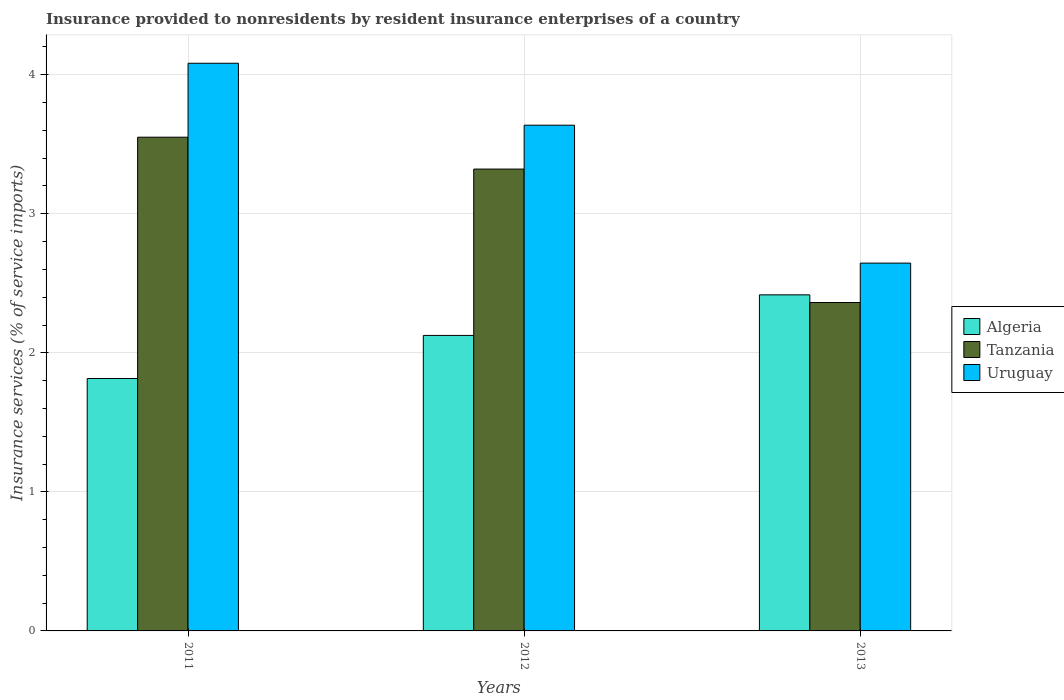How many different coloured bars are there?
Offer a very short reply. 3. What is the insurance provided to nonresidents in Tanzania in 2012?
Offer a very short reply. 3.32. Across all years, what is the maximum insurance provided to nonresidents in Algeria?
Your answer should be compact. 2.42. Across all years, what is the minimum insurance provided to nonresidents in Uruguay?
Your answer should be very brief. 2.65. What is the total insurance provided to nonresidents in Uruguay in the graph?
Your response must be concise. 10.36. What is the difference between the insurance provided to nonresidents in Uruguay in 2011 and that in 2012?
Your response must be concise. 0.45. What is the difference between the insurance provided to nonresidents in Uruguay in 2011 and the insurance provided to nonresidents in Algeria in 2013?
Make the answer very short. 1.67. What is the average insurance provided to nonresidents in Algeria per year?
Provide a short and direct response. 2.12. In the year 2013, what is the difference between the insurance provided to nonresidents in Tanzania and insurance provided to nonresidents in Algeria?
Give a very brief answer. -0.06. In how many years, is the insurance provided to nonresidents in Uruguay greater than 0.2 %?
Offer a very short reply. 3. What is the ratio of the insurance provided to nonresidents in Tanzania in 2011 to that in 2012?
Ensure brevity in your answer.  1.07. What is the difference between the highest and the second highest insurance provided to nonresidents in Algeria?
Your answer should be very brief. 0.29. What is the difference between the highest and the lowest insurance provided to nonresidents in Tanzania?
Give a very brief answer. 1.19. Is the sum of the insurance provided to nonresidents in Tanzania in 2011 and 2012 greater than the maximum insurance provided to nonresidents in Algeria across all years?
Offer a terse response. Yes. What does the 3rd bar from the left in 2013 represents?
Keep it short and to the point. Uruguay. What does the 2nd bar from the right in 2013 represents?
Ensure brevity in your answer.  Tanzania. Is it the case that in every year, the sum of the insurance provided to nonresidents in Tanzania and insurance provided to nonresidents in Uruguay is greater than the insurance provided to nonresidents in Algeria?
Offer a very short reply. Yes. How many bars are there?
Your answer should be very brief. 9. Are all the bars in the graph horizontal?
Ensure brevity in your answer.  No. How many years are there in the graph?
Offer a terse response. 3. What is the difference between two consecutive major ticks on the Y-axis?
Ensure brevity in your answer.  1. Are the values on the major ticks of Y-axis written in scientific E-notation?
Ensure brevity in your answer.  No. Does the graph contain any zero values?
Your answer should be very brief. No. Where does the legend appear in the graph?
Your answer should be compact. Center right. How are the legend labels stacked?
Give a very brief answer. Vertical. What is the title of the graph?
Provide a succinct answer. Insurance provided to nonresidents by resident insurance enterprises of a country. Does "Cyprus" appear as one of the legend labels in the graph?
Your answer should be very brief. No. What is the label or title of the Y-axis?
Your answer should be compact. Insurance services (% of service imports). What is the Insurance services (% of service imports) of Algeria in 2011?
Your answer should be compact. 1.82. What is the Insurance services (% of service imports) of Tanzania in 2011?
Provide a short and direct response. 3.55. What is the Insurance services (% of service imports) in Uruguay in 2011?
Keep it short and to the point. 4.08. What is the Insurance services (% of service imports) of Algeria in 2012?
Provide a short and direct response. 2.12. What is the Insurance services (% of service imports) of Tanzania in 2012?
Ensure brevity in your answer.  3.32. What is the Insurance services (% of service imports) in Uruguay in 2012?
Give a very brief answer. 3.64. What is the Insurance services (% of service imports) of Algeria in 2013?
Make the answer very short. 2.42. What is the Insurance services (% of service imports) in Tanzania in 2013?
Offer a very short reply. 2.36. What is the Insurance services (% of service imports) of Uruguay in 2013?
Offer a very short reply. 2.65. Across all years, what is the maximum Insurance services (% of service imports) in Algeria?
Your answer should be very brief. 2.42. Across all years, what is the maximum Insurance services (% of service imports) in Tanzania?
Offer a terse response. 3.55. Across all years, what is the maximum Insurance services (% of service imports) in Uruguay?
Make the answer very short. 4.08. Across all years, what is the minimum Insurance services (% of service imports) in Algeria?
Ensure brevity in your answer.  1.82. Across all years, what is the minimum Insurance services (% of service imports) of Tanzania?
Your answer should be very brief. 2.36. Across all years, what is the minimum Insurance services (% of service imports) of Uruguay?
Make the answer very short. 2.65. What is the total Insurance services (% of service imports) in Algeria in the graph?
Provide a short and direct response. 6.36. What is the total Insurance services (% of service imports) in Tanzania in the graph?
Ensure brevity in your answer.  9.23. What is the total Insurance services (% of service imports) of Uruguay in the graph?
Ensure brevity in your answer.  10.36. What is the difference between the Insurance services (% of service imports) in Algeria in 2011 and that in 2012?
Your answer should be very brief. -0.31. What is the difference between the Insurance services (% of service imports) of Tanzania in 2011 and that in 2012?
Your answer should be very brief. 0.23. What is the difference between the Insurance services (% of service imports) of Uruguay in 2011 and that in 2012?
Ensure brevity in your answer.  0.45. What is the difference between the Insurance services (% of service imports) of Algeria in 2011 and that in 2013?
Offer a very short reply. -0.6. What is the difference between the Insurance services (% of service imports) of Tanzania in 2011 and that in 2013?
Your response must be concise. 1.19. What is the difference between the Insurance services (% of service imports) of Uruguay in 2011 and that in 2013?
Ensure brevity in your answer.  1.44. What is the difference between the Insurance services (% of service imports) in Algeria in 2012 and that in 2013?
Provide a short and direct response. -0.29. What is the difference between the Insurance services (% of service imports) of Tanzania in 2012 and that in 2013?
Your answer should be very brief. 0.96. What is the difference between the Insurance services (% of service imports) of Uruguay in 2012 and that in 2013?
Your answer should be very brief. 0.99. What is the difference between the Insurance services (% of service imports) of Algeria in 2011 and the Insurance services (% of service imports) of Tanzania in 2012?
Keep it short and to the point. -1.51. What is the difference between the Insurance services (% of service imports) of Algeria in 2011 and the Insurance services (% of service imports) of Uruguay in 2012?
Give a very brief answer. -1.82. What is the difference between the Insurance services (% of service imports) of Tanzania in 2011 and the Insurance services (% of service imports) of Uruguay in 2012?
Offer a very short reply. -0.09. What is the difference between the Insurance services (% of service imports) in Algeria in 2011 and the Insurance services (% of service imports) in Tanzania in 2013?
Provide a short and direct response. -0.55. What is the difference between the Insurance services (% of service imports) in Algeria in 2011 and the Insurance services (% of service imports) in Uruguay in 2013?
Offer a terse response. -0.83. What is the difference between the Insurance services (% of service imports) in Tanzania in 2011 and the Insurance services (% of service imports) in Uruguay in 2013?
Offer a terse response. 0.91. What is the difference between the Insurance services (% of service imports) of Algeria in 2012 and the Insurance services (% of service imports) of Tanzania in 2013?
Offer a very short reply. -0.24. What is the difference between the Insurance services (% of service imports) in Algeria in 2012 and the Insurance services (% of service imports) in Uruguay in 2013?
Your answer should be very brief. -0.52. What is the difference between the Insurance services (% of service imports) of Tanzania in 2012 and the Insurance services (% of service imports) of Uruguay in 2013?
Keep it short and to the point. 0.68. What is the average Insurance services (% of service imports) in Algeria per year?
Offer a terse response. 2.12. What is the average Insurance services (% of service imports) of Tanzania per year?
Provide a short and direct response. 3.08. What is the average Insurance services (% of service imports) in Uruguay per year?
Ensure brevity in your answer.  3.45. In the year 2011, what is the difference between the Insurance services (% of service imports) of Algeria and Insurance services (% of service imports) of Tanzania?
Your answer should be very brief. -1.74. In the year 2011, what is the difference between the Insurance services (% of service imports) of Algeria and Insurance services (% of service imports) of Uruguay?
Keep it short and to the point. -2.27. In the year 2011, what is the difference between the Insurance services (% of service imports) in Tanzania and Insurance services (% of service imports) in Uruguay?
Make the answer very short. -0.53. In the year 2012, what is the difference between the Insurance services (% of service imports) of Algeria and Insurance services (% of service imports) of Tanzania?
Give a very brief answer. -1.2. In the year 2012, what is the difference between the Insurance services (% of service imports) of Algeria and Insurance services (% of service imports) of Uruguay?
Your answer should be compact. -1.51. In the year 2012, what is the difference between the Insurance services (% of service imports) in Tanzania and Insurance services (% of service imports) in Uruguay?
Your answer should be very brief. -0.32. In the year 2013, what is the difference between the Insurance services (% of service imports) in Algeria and Insurance services (% of service imports) in Tanzania?
Your response must be concise. 0.06. In the year 2013, what is the difference between the Insurance services (% of service imports) in Algeria and Insurance services (% of service imports) in Uruguay?
Provide a succinct answer. -0.23. In the year 2013, what is the difference between the Insurance services (% of service imports) in Tanzania and Insurance services (% of service imports) in Uruguay?
Provide a short and direct response. -0.28. What is the ratio of the Insurance services (% of service imports) of Algeria in 2011 to that in 2012?
Your response must be concise. 0.85. What is the ratio of the Insurance services (% of service imports) of Tanzania in 2011 to that in 2012?
Your answer should be very brief. 1.07. What is the ratio of the Insurance services (% of service imports) of Uruguay in 2011 to that in 2012?
Offer a very short reply. 1.12. What is the ratio of the Insurance services (% of service imports) of Algeria in 2011 to that in 2013?
Your answer should be compact. 0.75. What is the ratio of the Insurance services (% of service imports) in Tanzania in 2011 to that in 2013?
Offer a very short reply. 1.5. What is the ratio of the Insurance services (% of service imports) in Uruguay in 2011 to that in 2013?
Ensure brevity in your answer.  1.54. What is the ratio of the Insurance services (% of service imports) in Algeria in 2012 to that in 2013?
Offer a terse response. 0.88. What is the ratio of the Insurance services (% of service imports) of Tanzania in 2012 to that in 2013?
Your answer should be compact. 1.41. What is the ratio of the Insurance services (% of service imports) of Uruguay in 2012 to that in 2013?
Provide a succinct answer. 1.38. What is the difference between the highest and the second highest Insurance services (% of service imports) of Algeria?
Make the answer very short. 0.29. What is the difference between the highest and the second highest Insurance services (% of service imports) of Tanzania?
Ensure brevity in your answer.  0.23. What is the difference between the highest and the second highest Insurance services (% of service imports) of Uruguay?
Your response must be concise. 0.45. What is the difference between the highest and the lowest Insurance services (% of service imports) in Algeria?
Make the answer very short. 0.6. What is the difference between the highest and the lowest Insurance services (% of service imports) in Tanzania?
Make the answer very short. 1.19. What is the difference between the highest and the lowest Insurance services (% of service imports) in Uruguay?
Offer a very short reply. 1.44. 